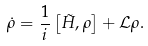<formula> <loc_0><loc_0><loc_500><loc_500>\dot { \rho } = \frac { 1 } { i } \left [ \tilde { H } , \rho \right ] + \mathcal { L } \rho .</formula> 